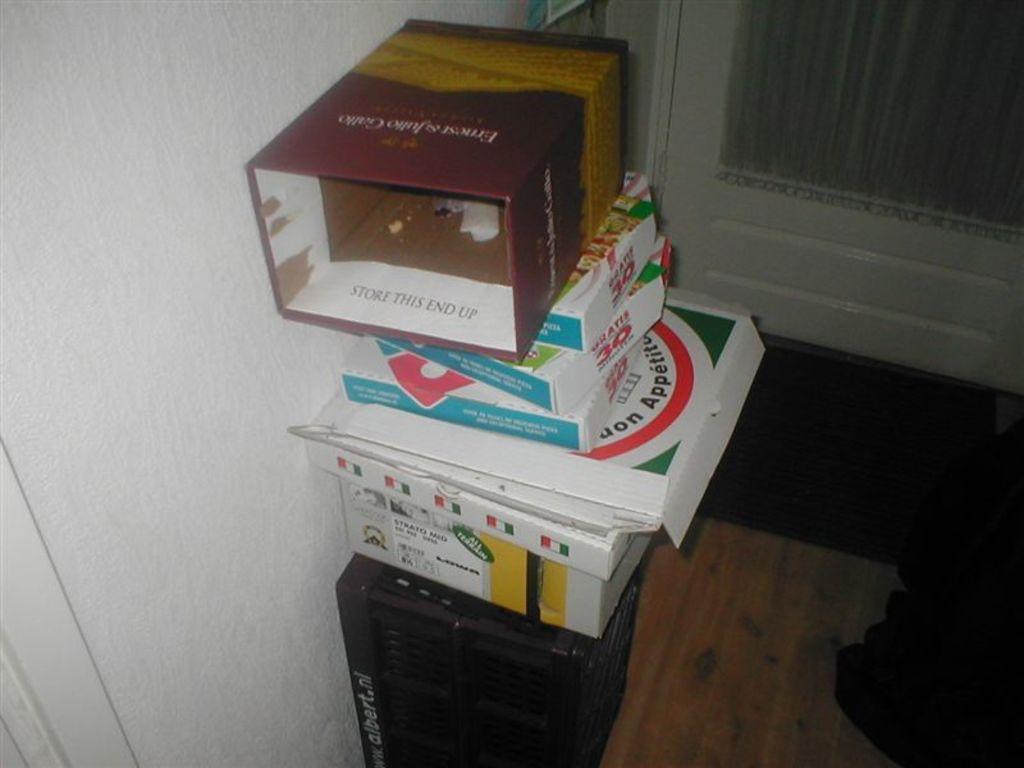Store which end up?
Give a very brief answer. This end. 